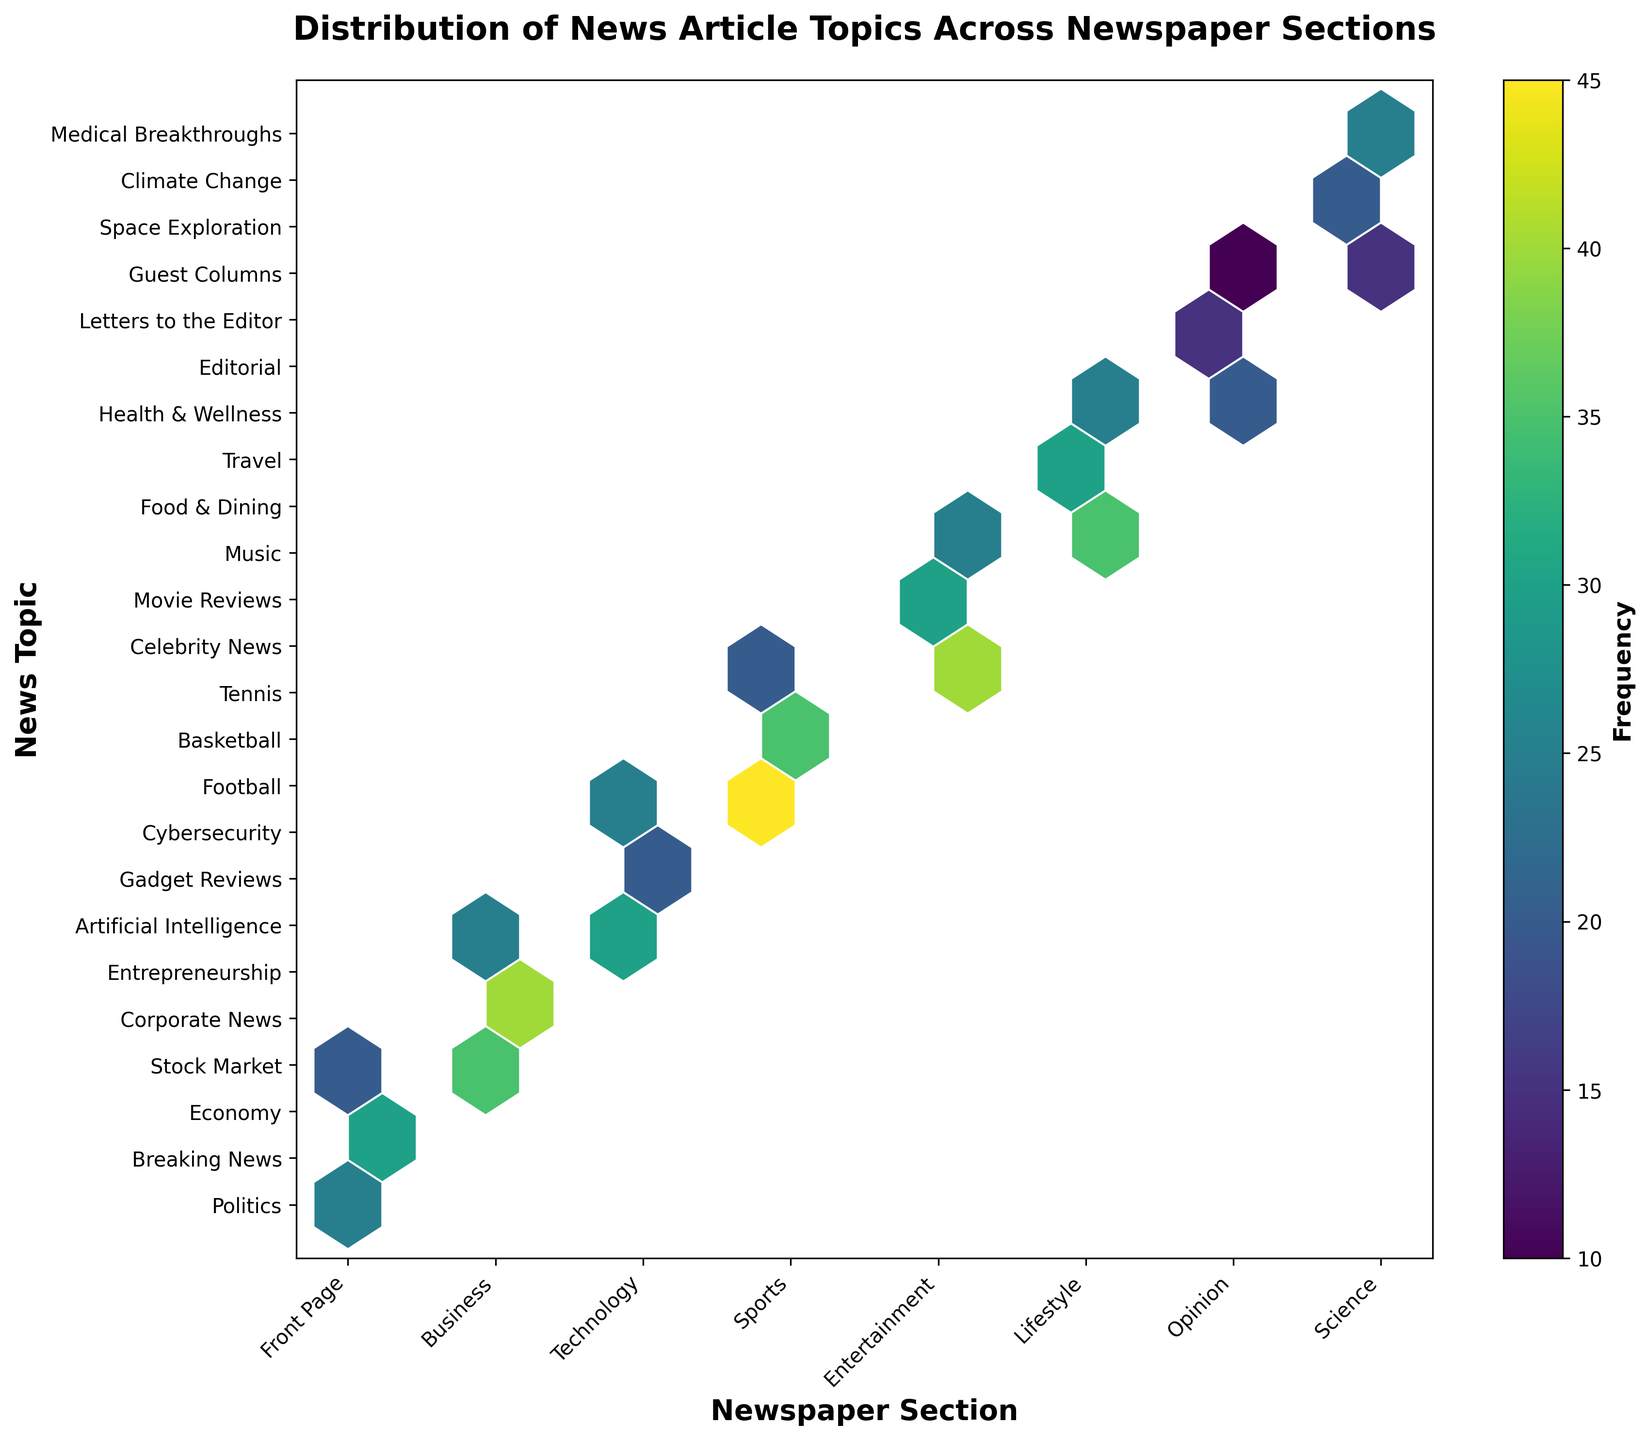what is the title of the figure? The title can be found at the top of the figure and it succinctly describes the content of the plot.
Answer: Distribution of News Article Topics Across Newspaper Sections what does the color represent in the Hexbin Plot? The color represents the frequency of the news topics within the various sections of the newspaper. Darker colors indicate higher frequencies.
Answer: Frequency how many newspaper sections are there in the plot? Count the number of unique section labels on the x-axis.
Answer: 7 what is the most frequent topic in the Sports section? Identify the color with the highest intensity within the Sports section and cross-reference with the y-axis labels to find the topic with the highest frequency.
Answer: Football which topic appears least frequently in the Opinion section? Locate the Opinion section on the x-axis and find the point within that section with the lightest color intensity. Match it with the corresponding y-axis label.
Answer: Guest Columns what is the range of frequency values depicted in the color bar? The range of frequency values can be read directly from the color bar on the right side of the plot.
Answer: 10-45 which section has the highest number of topics with a frequency greater than 30? Identify sections where multiple hexagons have a darker intensity (greater than 30 on the color bar), then count the number of these hexagons for comparison.
Answer: Sports how does the frequency of Gadget Reviews in Technology compare to that of Football in Sports? Find the color intensity for both Gadget Reviews in Technology and Football in Sports. Compare their colors based on the color bar's frequency indication.
Answer: Gadget Reviews is less frequent than Football what is the average frequency of topics in the Entertainment section? Identify the frequency values for each topic in the Entertainment section and calculate their average. Values are 40, 30 and 25. The average is (40+30+25)/3 = 31.67
Answer: 31.67 which sections have a wider variety of topics in terms of frequency, Business or Lifestyle? Compare the range of color intensities (frequency) for topics within the Business and Lifestyle sections.
Answer: Business 